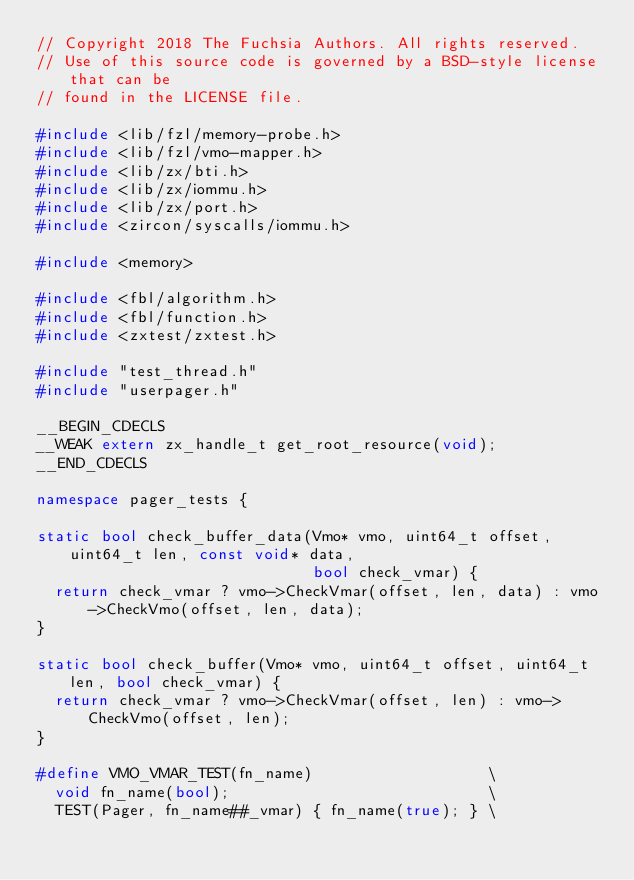Convert code to text. <code><loc_0><loc_0><loc_500><loc_500><_C++_>// Copyright 2018 The Fuchsia Authors. All rights reserved.
// Use of this source code is governed by a BSD-style license that can be
// found in the LICENSE file.

#include <lib/fzl/memory-probe.h>
#include <lib/fzl/vmo-mapper.h>
#include <lib/zx/bti.h>
#include <lib/zx/iommu.h>
#include <lib/zx/port.h>
#include <zircon/syscalls/iommu.h>

#include <memory>

#include <fbl/algorithm.h>
#include <fbl/function.h>
#include <zxtest/zxtest.h>

#include "test_thread.h"
#include "userpager.h"

__BEGIN_CDECLS
__WEAK extern zx_handle_t get_root_resource(void);
__END_CDECLS

namespace pager_tests {

static bool check_buffer_data(Vmo* vmo, uint64_t offset, uint64_t len, const void* data,
                              bool check_vmar) {
  return check_vmar ? vmo->CheckVmar(offset, len, data) : vmo->CheckVmo(offset, len, data);
}

static bool check_buffer(Vmo* vmo, uint64_t offset, uint64_t len, bool check_vmar) {
  return check_vmar ? vmo->CheckVmar(offset, len) : vmo->CheckVmo(offset, len);
}

#define VMO_VMAR_TEST(fn_name)                   \
  void fn_name(bool);                            \
  TEST(Pager, fn_name##_vmar) { fn_name(true); } \</code> 